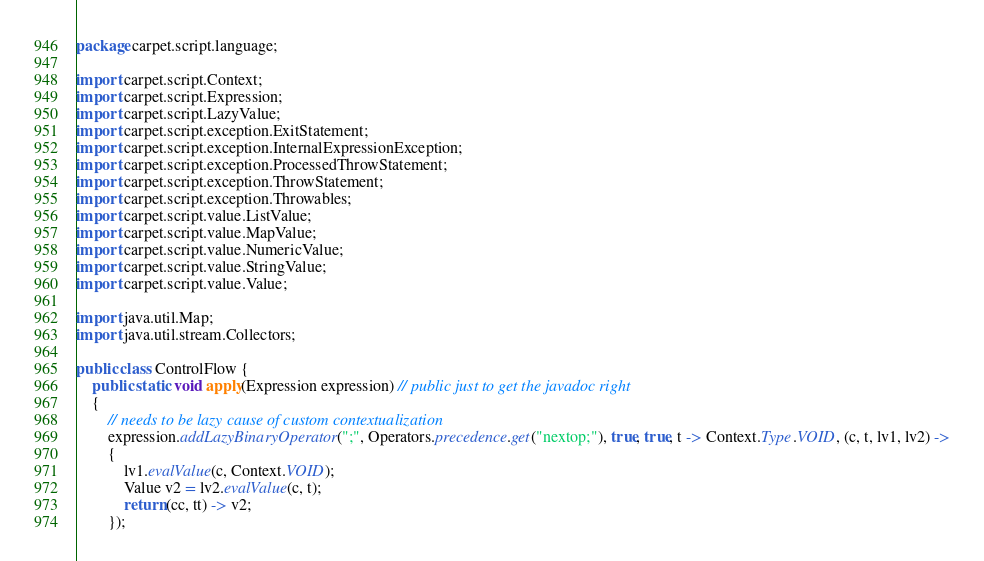<code> <loc_0><loc_0><loc_500><loc_500><_Java_>package carpet.script.language;

import carpet.script.Context;
import carpet.script.Expression;
import carpet.script.LazyValue;
import carpet.script.exception.ExitStatement;
import carpet.script.exception.InternalExpressionException;
import carpet.script.exception.ProcessedThrowStatement;
import carpet.script.exception.ThrowStatement;
import carpet.script.exception.Throwables;
import carpet.script.value.ListValue;
import carpet.script.value.MapValue;
import carpet.script.value.NumericValue;
import carpet.script.value.StringValue;
import carpet.script.value.Value;

import java.util.Map;
import java.util.stream.Collectors;

public class ControlFlow {
    public static void apply(Expression expression) // public just to get the javadoc right
    {
        // needs to be lazy cause of custom contextualization
        expression.addLazyBinaryOperator(";", Operators.precedence.get("nextop;"), true, true, t -> Context.Type.VOID, (c, t, lv1, lv2) ->
        {
            lv1.evalValue(c, Context.VOID);
            Value v2 = lv2.evalValue(c, t);
            return (cc, tt) -> v2;
        });
</code> 